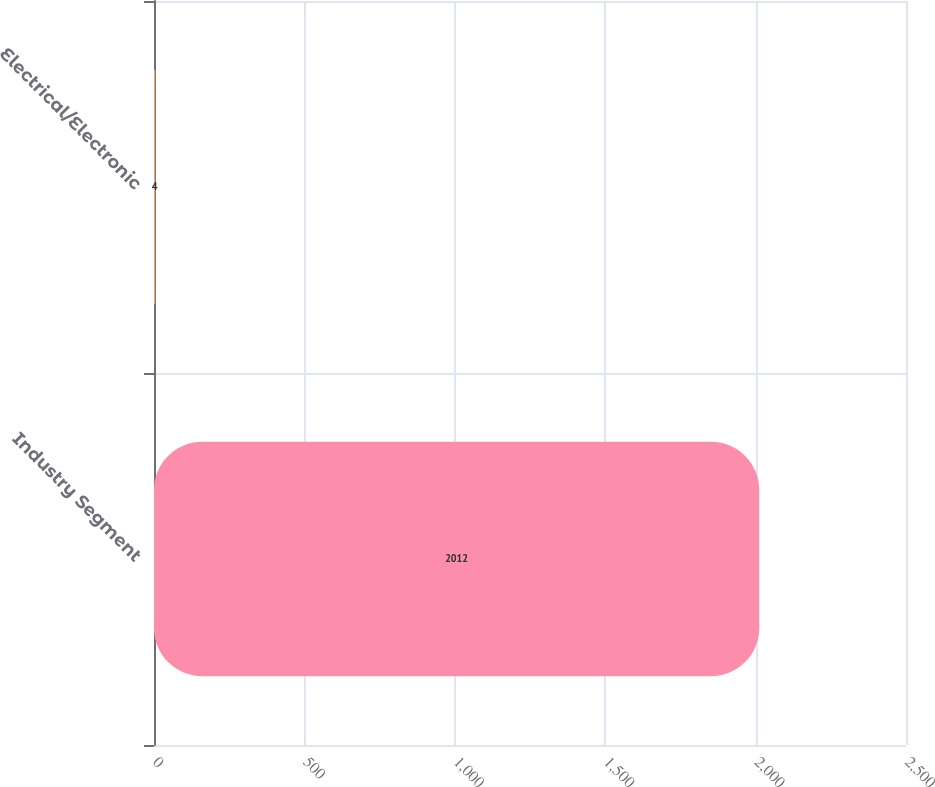Convert chart to OTSL. <chart><loc_0><loc_0><loc_500><loc_500><bar_chart><fcel>Industry Segment<fcel>Electrical/Electronic<nl><fcel>2012<fcel>4<nl></chart> 